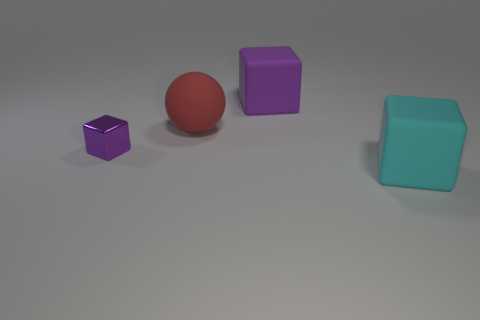Subtract all purple blocks. How many were subtracted if there are1purple blocks left? 1 Add 2 big matte spheres. How many objects exist? 6 Subtract all blocks. How many objects are left? 1 Add 3 big balls. How many big balls are left? 4 Add 2 big yellow matte spheres. How many big yellow matte spheres exist? 2 Subtract 0 red blocks. How many objects are left? 4 Subtract all big purple rubber objects. Subtract all cyan rubber cubes. How many objects are left? 2 